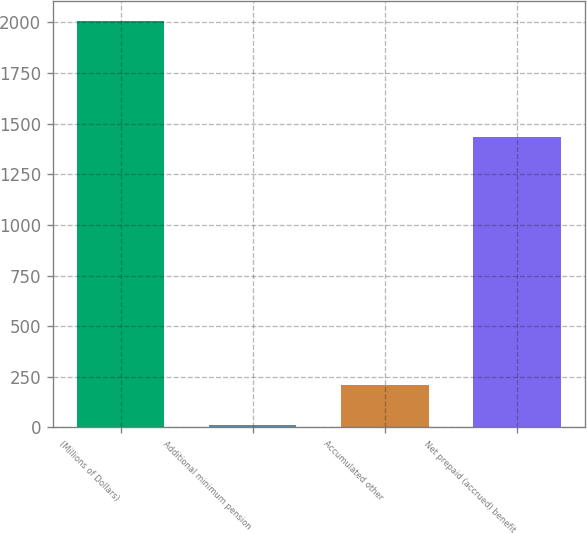<chart> <loc_0><loc_0><loc_500><loc_500><bar_chart><fcel>(Millions of Dollars)<fcel>Additional minimum pension<fcel>Accumulated other<fcel>Net prepaid (accrued) benefit<nl><fcel>2004<fcel>11<fcel>210.3<fcel>1435<nl></chart> 